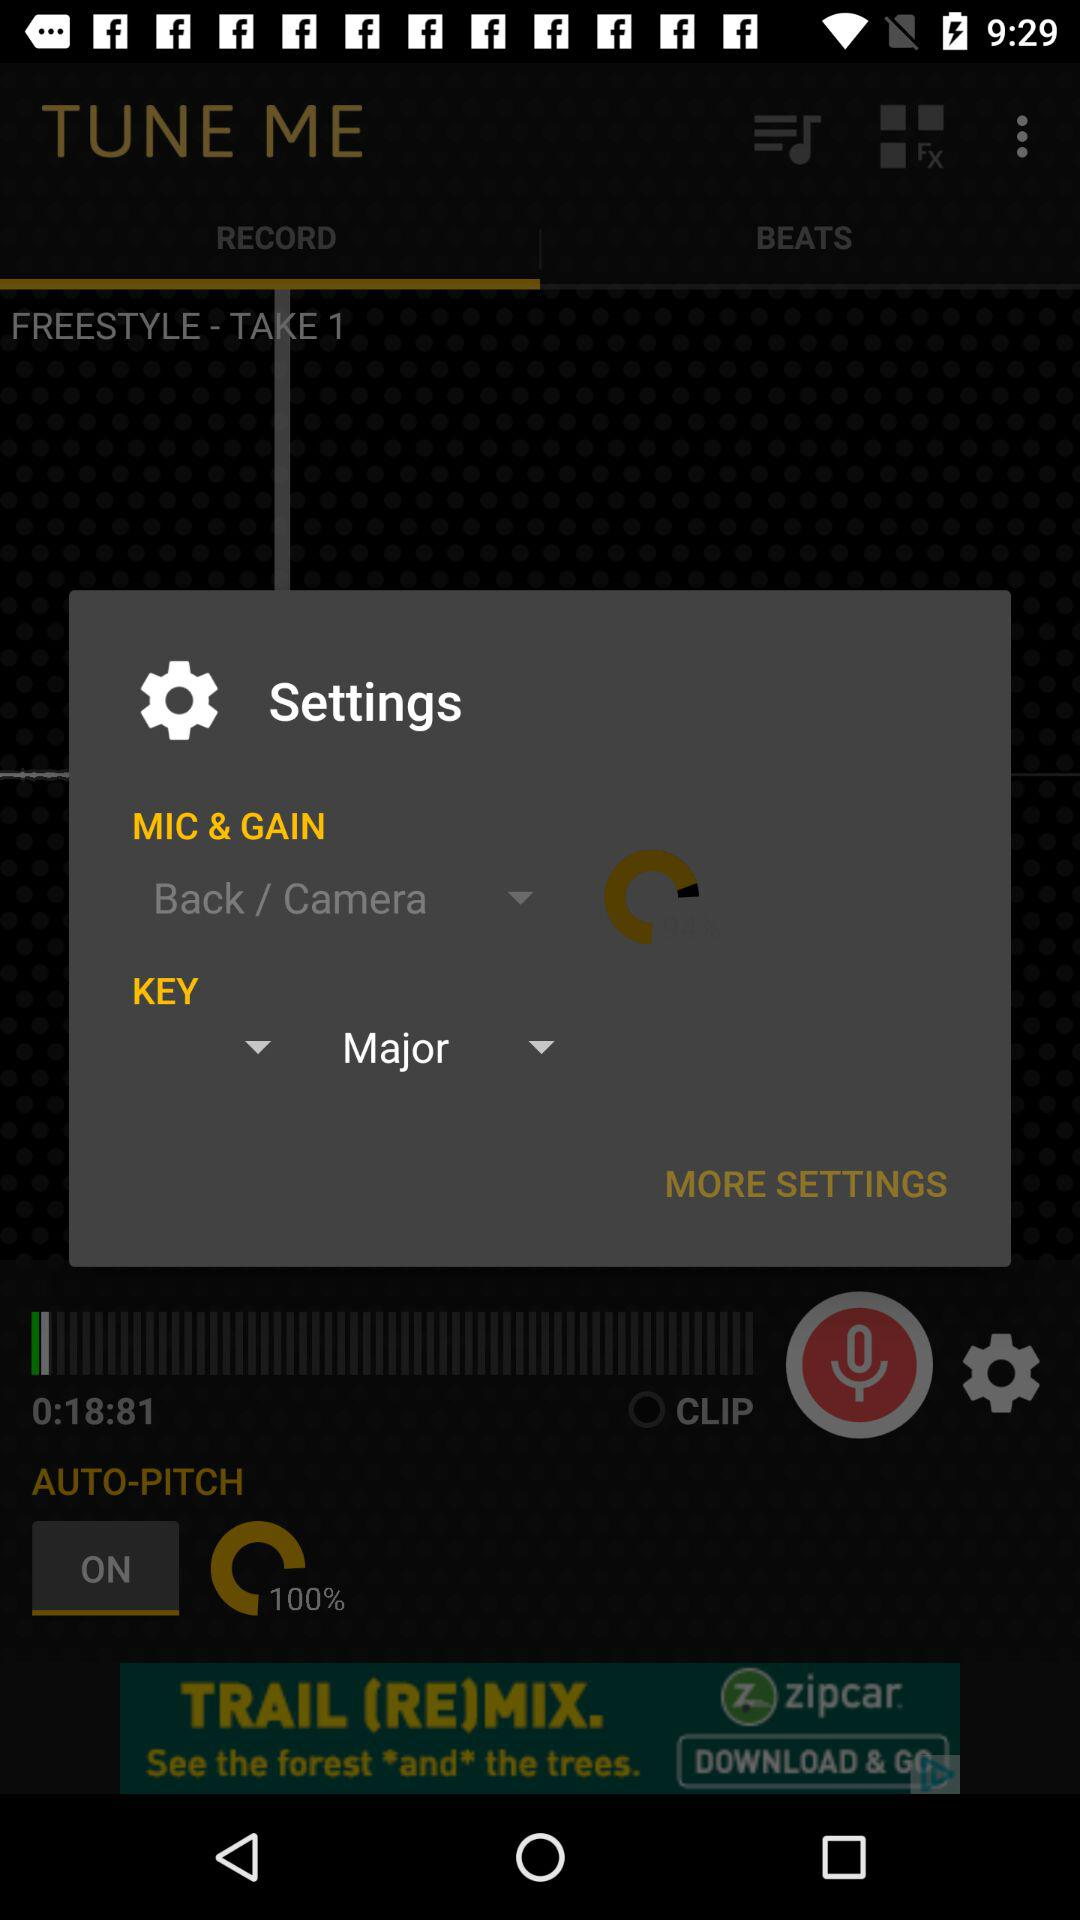What is the selected key? The selected key is "Major". 